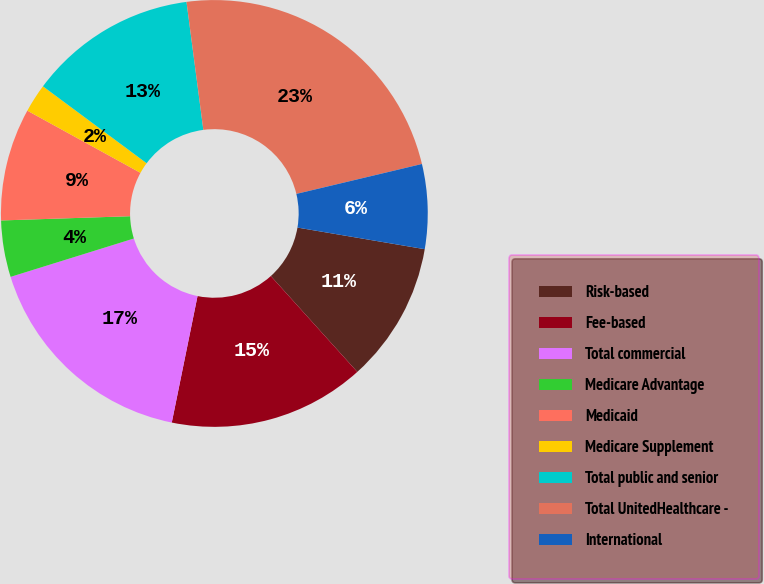<chart> <loc_0><loc_0><loc_500><loc_500><pie_chart><fcel>Risk-based<fcel>Fee-based<fcel>Total commercial<fcel>Medicare Advantage<fcel>Medicaid<fcel>Medicare Supplement<fcel>Total public and senior<fcel>Total UnitedHealthcare -<fcel>International<nl><fcel>10.64%<fcel>14.88%<fcel>17.0%<fcel>4.28%<fcel>8.52%<fcel>2.16%<fcel>12.76%<fcel>23.36%<fcel>6.4%<nl></chart> 